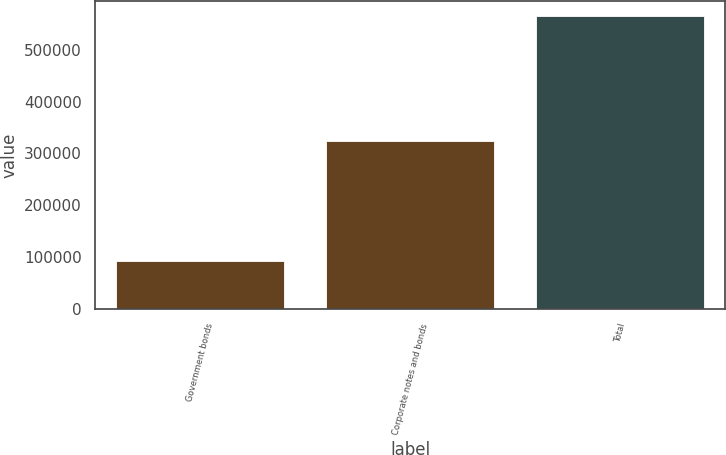<chart> <loc_0><loc_0><loc_500><loc_500><bar_chart><fcel>Government bonds<fcel>Corporate notes and bonds<fcel>Total<nl><fcel>92341<fcel>324800<fcel>565691<nl></chart> 